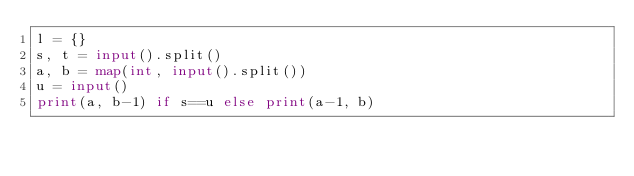<code> <loc_0><loc_0><loc_500><loc_500><_Python_>l = {}
s, t = input().split()
a, b = map(int, input().split())
u = input()
print(a, b-1) if s==u else print(a-1, b)
</code> 